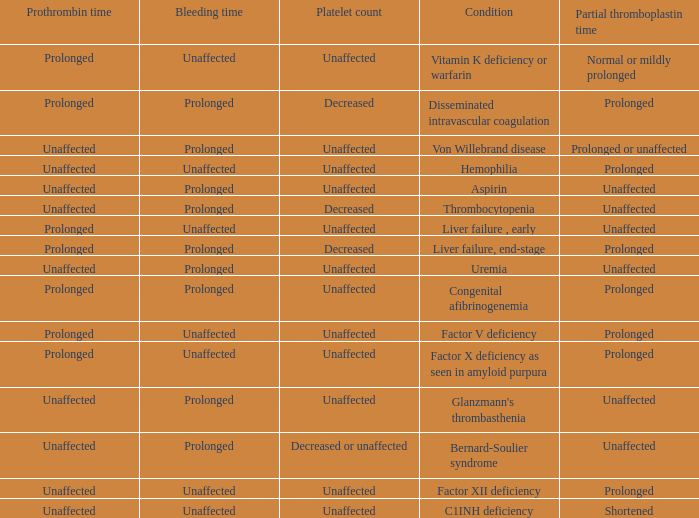Which Platelet count has a Condition of factor v deficiency? Unaffected. 